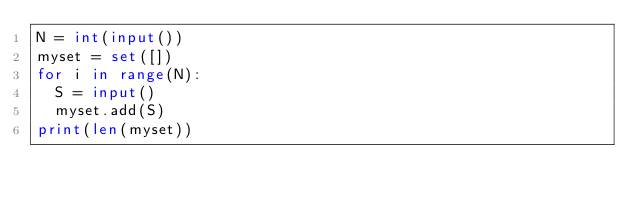Convert code to text. <code><loc_0><loc_0><loc_500><loc_500><_Python_>N = int(input())
myset = set([])
for i in range(N):
  S = input()
  myset.add(S)
print(len(myset))
</code> 